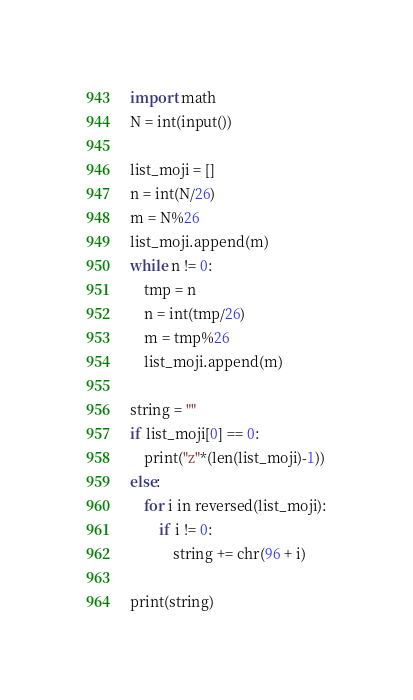Convert code to text. <code><loc_0><loc_0><loc_500><loc_500><_Python_>import math
N = int(input())

list_moji = []
n = int(N/26)
m = N%26
list_moji.append(m)
while n != 0:
    tmp = n
    n = int(tmp/26)
    m = tmp%26
    list_moji.append(m)

string = ""
if list_moji[0] == 0:
    print("z"*(len(list_moji)-1))
else:
    for i in reversed(list_moji):
        if i != 0:
            string += chr(96 + i)

print(string)</code> 